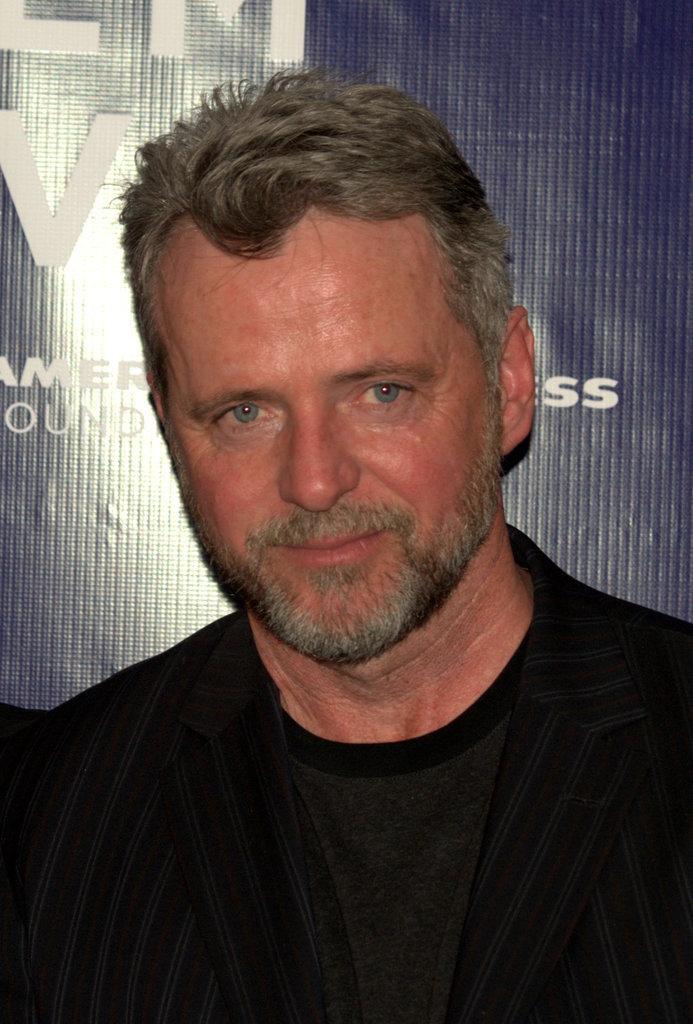Describe this image in one or two sentences. In this image there is a person, behind the person there is a banner with text. 